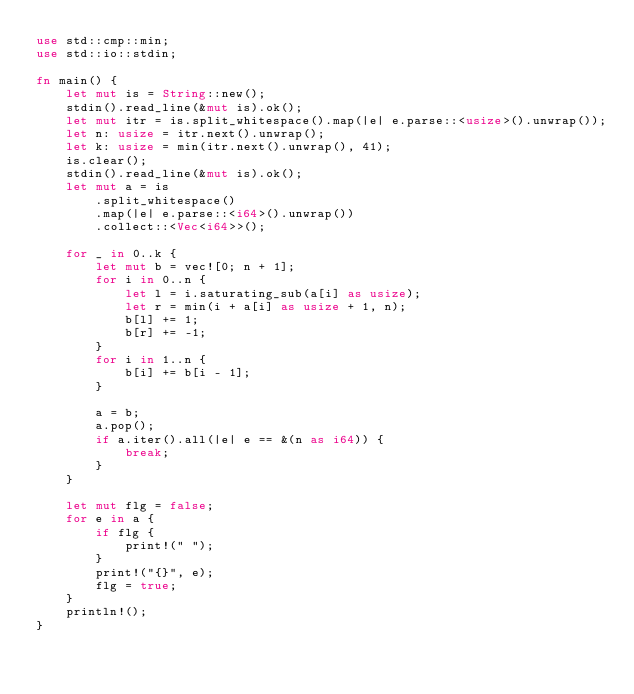Convert code to text. <code><loc_0><loc_0><loc_500><loc_500><_Rust_>use std::cmp::min;
use std::io::stdin;

fn main() {
    let mut is = String::new();
    stdin().read_line(&mut is).ok();
    let mut itr = is.split_whitespace().map(|e| e.parse::<usize>().unwrap());
    let n: usize = itr.next().unwrap();
    let k: usize = min(itr.next().unwrap(), 41);
    is.clear();
    stdin().read_line(&mut is).ok();
    let mut a = is
        .split_whitespace()
        .map(|e| e.parse::<i64>().unwrap())
        .collect::<Vec<i64>>();

    for _ in 0..k {
        let mut b = vec![0; n + 1];
        for i in 0..n {
            let l = i.saturating_sub(a[i] as usize);
            let r = min(i + a[i] as usize + 1, n);
            b[l] += 1;
            b[r] += -1;
        }
        for i in 1..n {
            b[i] += b[i - 1];
        }

        a = b;
        a.pop();
        if a.iter().all(|e| e == &(n as i64)) {
            break;
        }
    }

    let mut flg = false;
    for e in a {
        if flg {
            print!(" ");
        }
        print!("{}", e);
        flg = true;
    }
    println!();
}
</code> 